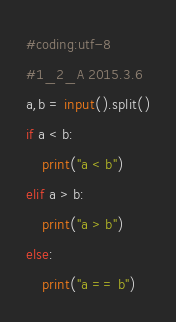Convert code to text. <code><loc_0><loc_0><loc_500><loc_500><_Python_>#coding:utf-8
#1_2_A 2015.3.6
a,b = input().split()
if a < b:
    print("a < b")
elif a > b:
    print("a > b")
else:
    print("a == b")</code> 